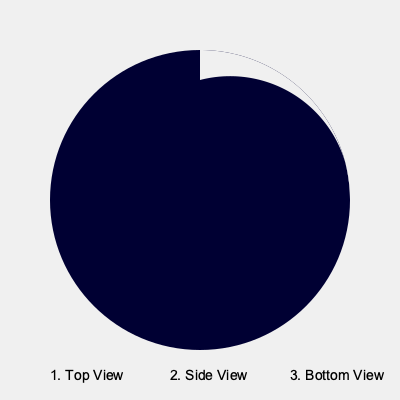During the early days of Ramadan, you observe a waxing crescent moon. If you were to view this crescent moon from different angles, which of the numbered options in the image above would correctly represent its appearance from the bottom view? To answer this question, we need to consider the following steps:

1. Understand the moon's phases: The waxing crescent moon appears in the early days of the lunar month, including Ramadan. It's visible as a thin crescent on the right side when viewed from the Northern Hemisphere.

2. Analyze the given views:
   - Top view: Shows the crescent on the right side, which is correct for a waxing crescent.
   - Side view: Shows the full circular shape of the moon, with the illuminated part on the right.
   - Bottom view: Shows the crescent on the left side.

3. Consider the perspective change:
   - When viewing from the bottom, we're essentially rotating the moon 180 degrees around its horizontal axis.
   - This rotation would flip the crescent from right to left.

4. Apply Islamic astronomical knowledge:
   - In Islamic tradition, the crescent moon's appearance marks the beginning of new months, including Ramadan.
   - Understanding its orientation is crucial for determining the start and end of religious observances.

5. Conclusion:
   - The bottom view (option 3) correctly represents how the waxing crescent would appear if viewed from below.

This analysis combines modern astronomical understanding with the importance of lunar observation in Islamic practice, aligning with the persona of a devout Muslim who balances scientific knowledge and traditional teachings.
Answer: 3 